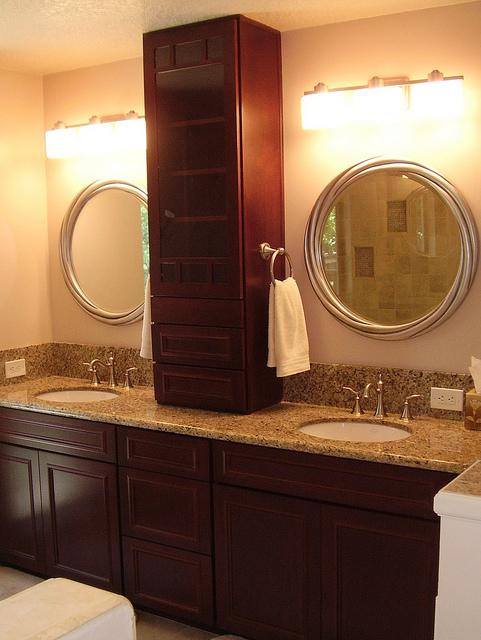How many mirrors are here?
Answer briefly. 2. Is the room clean?
Concise answer only. Yes. What room is this?
Answer briefly. Bathroom. 